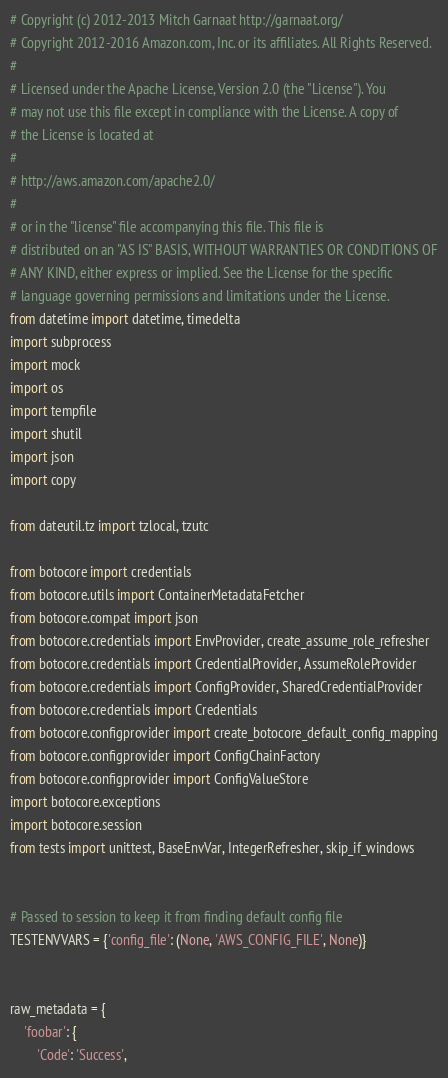<code> <loc_0><loc_0><loc_500><loc_500><_Python_># Copyright (c) 2012-2013 Mitch Garnaat http://garnaat.org/
# Copyright 2012-2016 Amazon.com, Inc. or its affiliates. All Rights Reserved.
#
# Licensed under the Apache License, Version 2.0 (the "License"). You
# may not use this file except in compliance with the License. A copy of
# the License is located at
#
# http://aws.amazon.com/apache2.0/
#
# or in the "license" file accompanying this file. This file is
# distributed on an "AS IS" BASIS, WITHOUT WARRANTIES OR CONDITIONS OF
# ANY KIND, either express or implied. See the License for the specific
# language governing permissions and limitations under the License.
from datetime import datetime, timedelta
import subprocess
import mock
import os
import tempfile
import shutil
import json
import copy

from dateutil.tz import tzlocal, tzutc

from botocore import credentials
from botocore.utils import ContainerMetadataFetcher
from botocore.compat import json
from botocore.credentials import EnvProvider, create_assume_role_refresher
from botocore.credentials import CredentialProvider, AssumeRoleProvider
from botocore.credentials import ConfigProvider, SharedCredentialProvider
from botocore.credentials import Credentials
from botocore.configprovider import create_botocore_default_config_mapping
from botocore.configprovider import ConfigChainFactory
from botocore.configprovider import ConfigValueStore
import botocore.exceptions
import botocore.session
from tests import unittest, BaseEnvVar, IntegerRefresher, skip_if_windows


# Passed to session to keep it from finding default config file
TESTENVVARS = {'config_file': (None, 'AWS_CONFIG_FILE', None)}


raw_metadata = {
    'foobar': {
        'Code': 'Success',</code> 